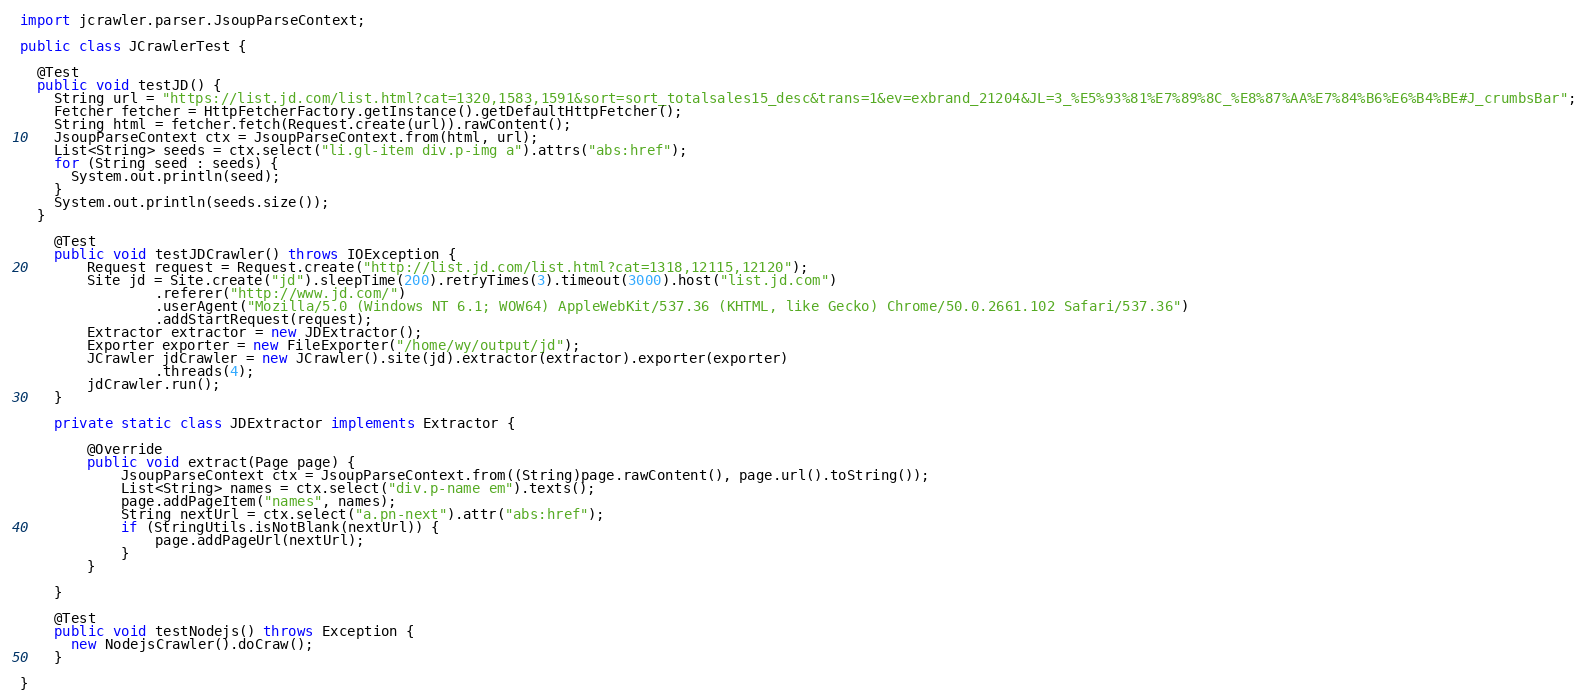<code> <loc_0><loc_0><loc_500><loc_500><_Java_>import jcrawler.parser.JsoupParseContext;

public class JCrawlerTest {
  
  @Test
  public void testJD() {
    String url = "https://list.jd.com/list.html?cat=1320,1583,1591&sort=sort_totalsales15_desc&trans=1&ev=exbrand_21204&JL=3_%E5%93%81%E7%89%8C_%E8%87%AA%E7%84%B6%E6%B4%BE#J_crumbsBar";
    Fetcher fetcher = HttpFetcherFactory.getInstance().getDefaultHttpFetcher();
    String html = fetcher.fetch(Request.create(url)).rawContent();
    JsoupParseContext ctx = JsoupParseContext.from(html, url);
    List<String> seeds = ctx.select("li.gl-item div.p-img a").attrs("abs:href");
    for (String seed : seeds) {
      System.out.println(seed);
    }
    System.out.println(seeds.size());
  }

	@Test
	public void testJDCrawler() throws IOException {
		Request request = Request.create("http://list.jd.com/list.html?cat=1318,12115,12120");
		Site jd = Site.create("jd").sleepTime(200).retryTimes(3).timeout(3000).host("list.jd.com")
				.referer("http://www.jd.com/")
				.userAgent("Mozilla/5.0 (Windows NT 6.1; WOW64) AppleWebKit/537.36 (KHTML, like Gecko) Chrome/50.0.2661.102 Safari/537.36")
				.addStartRequest(request);
		Extractor extractor = new JDExtractor();
		Exporter exporter = new FileExporter("/home/wy/output/jd");
		JCrawler jdCrawler = new JCrawler().site(jd).extractor(extractor).exporter(exporter)
				.threads(4);
		jdCrawler.run();
	}
	
	private static class JDExtractor implements Extractor {

		@Override
		public void extract(Page page) {
			JsoupParseContext ctx = JsoupParseContext.from((String)page.rawContent(), page.url().toString());
			List<String> names = ctx.select("div.p-name em").texts();
			page.addPageItem("names", names);
			String nextUrl = ctx.select("a.pn-next").attr("abs:href");
			if (StringUtils.isNotBlank(nextUrl)) {
				page.addPageUrl(nextUrl);
			}
		}
		
	}
	
	@Test
	public void testNodejs() throws Exception {
	  new NodejsCrawler().doCraw();
	}

}
</code> 